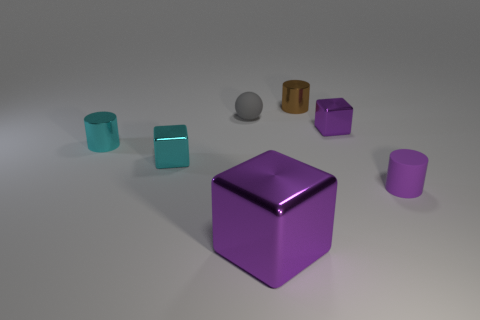Are there any tiny metallic cubes that have the same color as the large cube?
Offer a terse response. Yes. Is the size of the shiny block in front of the purple cylinder the same as the small purple cube?
Offer a terse response. No. There is a matte thing on the left side of the purple rubber thing; what is its size?
Your answer should be very brief. Small. Are the gray ball and the tiny brown object made of the same material?
Provide a short and direct response. No. There is a shiny cylinder left of the ball that is to the right of the tiny cyan shiny cube; is there a big purple metallic object on the left side of it?
Give a very brief answer. No. The big block is what color?
Your answer should be compact. Purple. What color is the other block that is the same size as the cyan cube?
Provide a short and direct response. Purple. There is a matte object to the right of the tiny brown object; is it the same shape as the large purple object?
Your answer should be very brief. No. There is a small matte object behind the cylinder that is on the left side of the big purple cube that is in front of the brown metal cylinder; what color is it?
Ensure brevity in your answer.  Gray. Are any gray matte balls visible?
Your response must be concise. Yes. 